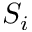<formula> <loc_0><loc_0><loc_500><loc_500>S _ { i }</formula> 